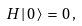Convert formula to latex. <formula><loc_0><loc_0><loc_500><loc_500>H \, | \, 0 \, \rangle \, = \, 0 \, ,</formula> 